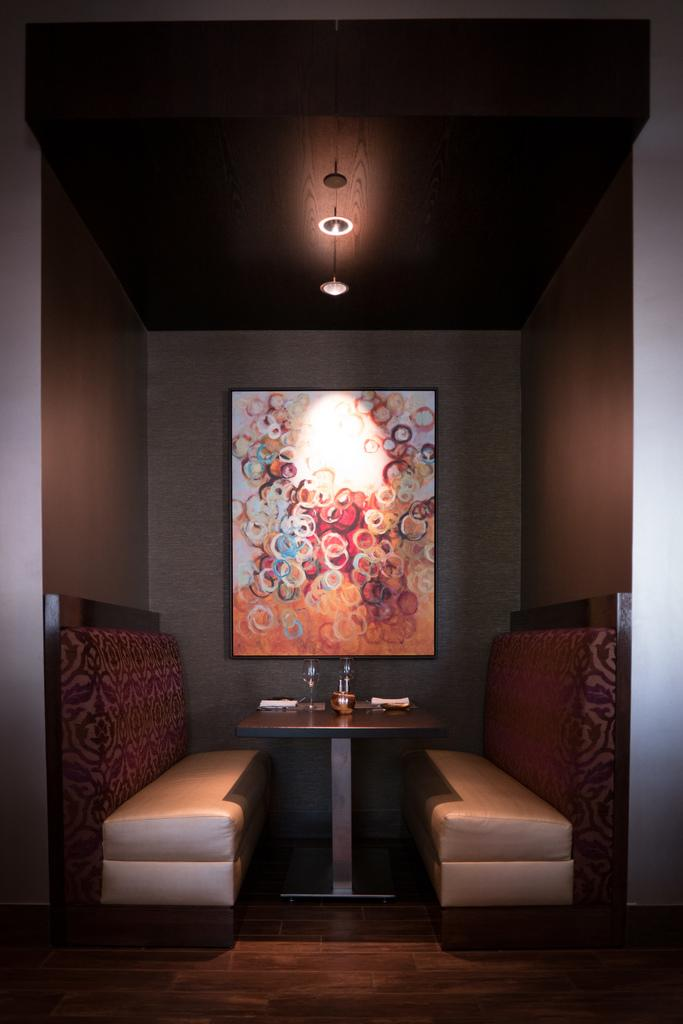How many couches are in the image? There are two couches in the image. What other furniture can be seen in the image? There is a table in the background of the image. What is attached to a wall in the image? There is a frame attached to a wall in the image. What is visible at the top of the image? There is a light visible at the top of the image. What type of trail can be seen leading to the couches in the image? There is no trail visible in the image; it features two couches, a table, a frame, and a light. 